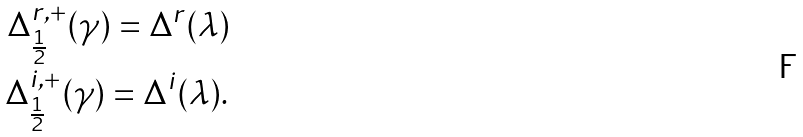Convert formula to latex. <formula><loc_0><loc_0><loc_500><loc_500>\Delta _ { \frac { 1 } { 2 } } ^ { r , + } ( \gamma ) = \Delta ^ { r } ( \lambda ) \\ \Delta _ { \frac { 1 } { 2 } } ^ { i , + } ( \gamma ) = \Delta ^ { i } ( \lambda ) .</formula> 